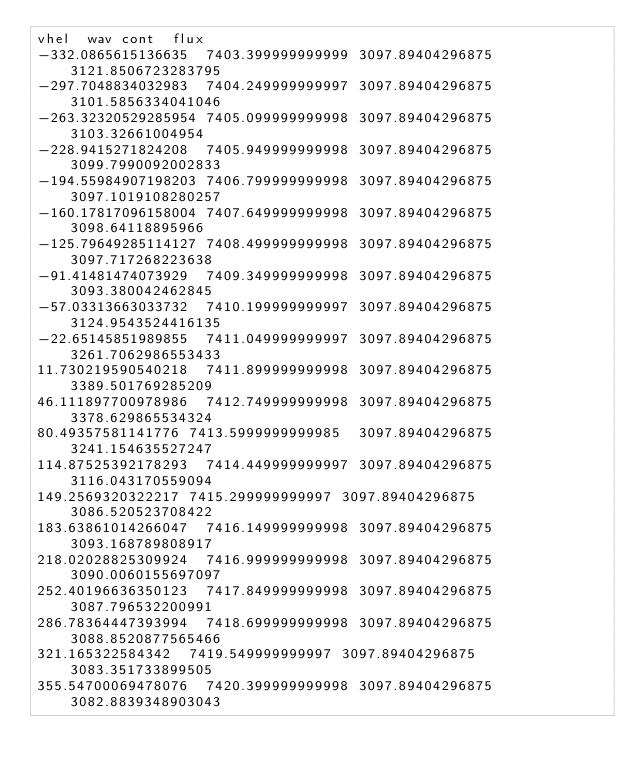<code> <loc_0><loc_0><loc_500><loc_500><_SQL_>vhel	wav	cont	flux
-332.0865615136635	7403.399999999999	3097.89404296875	3121.8506723283795
-297.7048834032983	7404.249999999997	3097.89404296875	3101.5856334041046
-263.32320529285954	7405.099999999998	3097.89404296875	3103.32661004954
-228.9415271824208	7405.949999999998	3097.89404296875	3099.7990092002833
-194.55984907198203	7406.799999999998	3097.89404296875	3097.1019108280257
-160.17817096158004	7407.649999999998	3097.89404296875	3098.64118895966
-125.79649285114127	7408.499999999998	3097.89404296875	3097.717268223638
-91.41481474073929	7409.349999999998	3097.89404296875	3093.380042462845
-57.03313663033732	7410.199999999997	3097.89404296875	3124.9543524416135
-22.65145851989855	7411.049999999997	3097.89404296875	3261.7062986553433
11.730219590540218	7411.899999999998	3097.89404296875	3389.501769285209
46.111897700978986	7412.749999999998	3097.89404296875	3378.629865534324
80.49357581141776	7413.5999999999985	3097.89404296875	3241.154635527247
114.87525392178293	7414.449999999997	3097.89404296875	3116.043170559094
149.2569320322217	7415.299999999997	3097.89404296875	3086.520523708422
183.63861014266047	7416.149999999998	3097.89404296875	3093.168789808917
218.02028825309924	7416.999999999998	3097.89404296875	3090.0060155697097
252.40196636350123	7417.849999999998	3097.89404296875	3087.796532200991
286.78364447393994	7418.699999999998	3097.89404296875	3088.8520877565466
321.165322584342	7419.549999999997	3097.89404296875	3083.351733899505
355.54700069478076	7420.399999999998	3097.89404296875	3082.8839348903043
</code> 